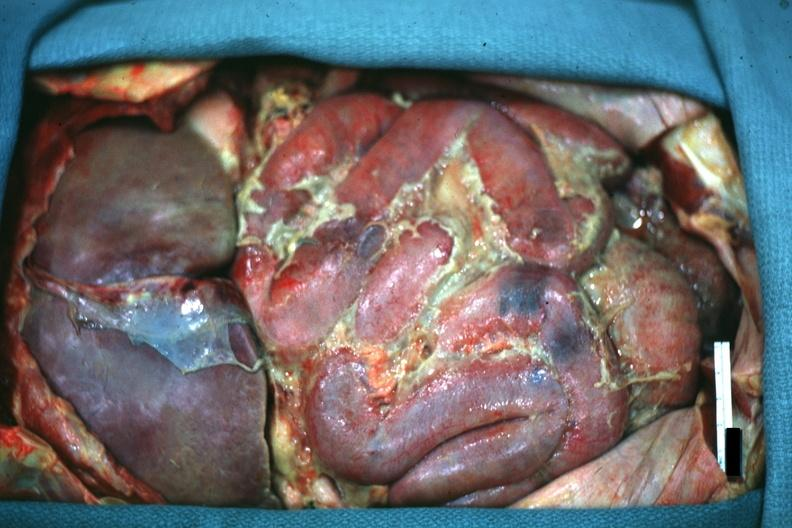what is present?
Answer the question using a single word or phrase. Peritoneum 